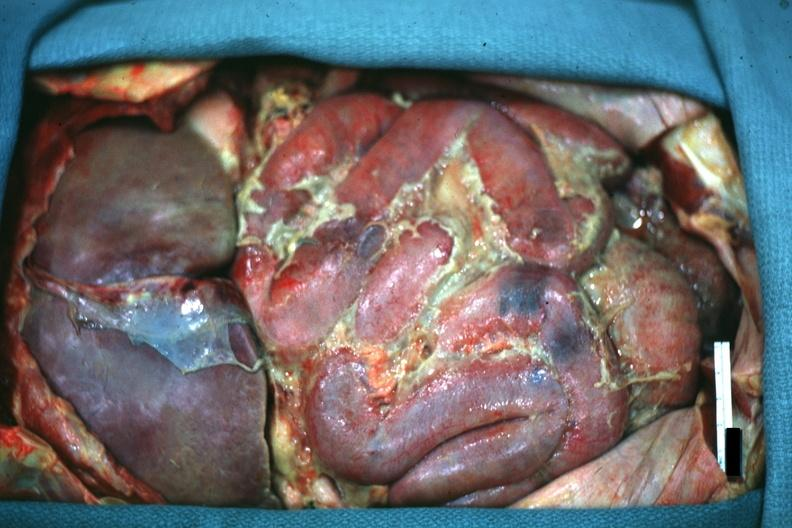what is present?
Answer the question using a single word or phrase. Peritoneum 